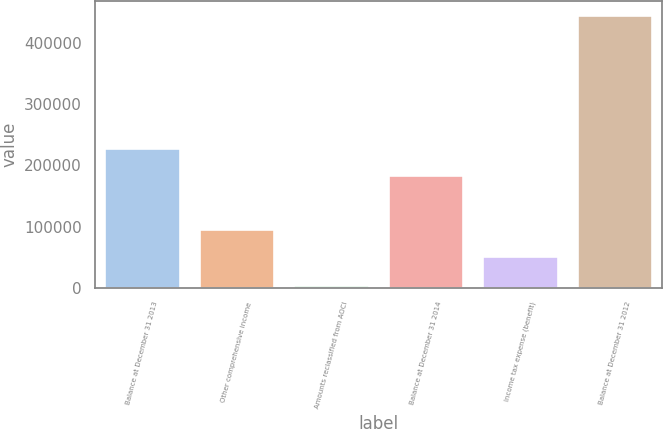Convert chart. <chart><loc_0><loc_0><loc_500><loc_500><bar_chart><fcel>Balance at December 31 2013<fcel>Other comprehensive income<fcel>Amounts reclassified from AOCI<fcel>Balance at December 31 2014<fcel>Income tax expense (benefit)<fcel>Balance at December 31 2012<nl><fcel>228907<fcel>96600.2<fcel>5135<fcel>184805<fcel>52498<fcel>446157<nl></chart> 